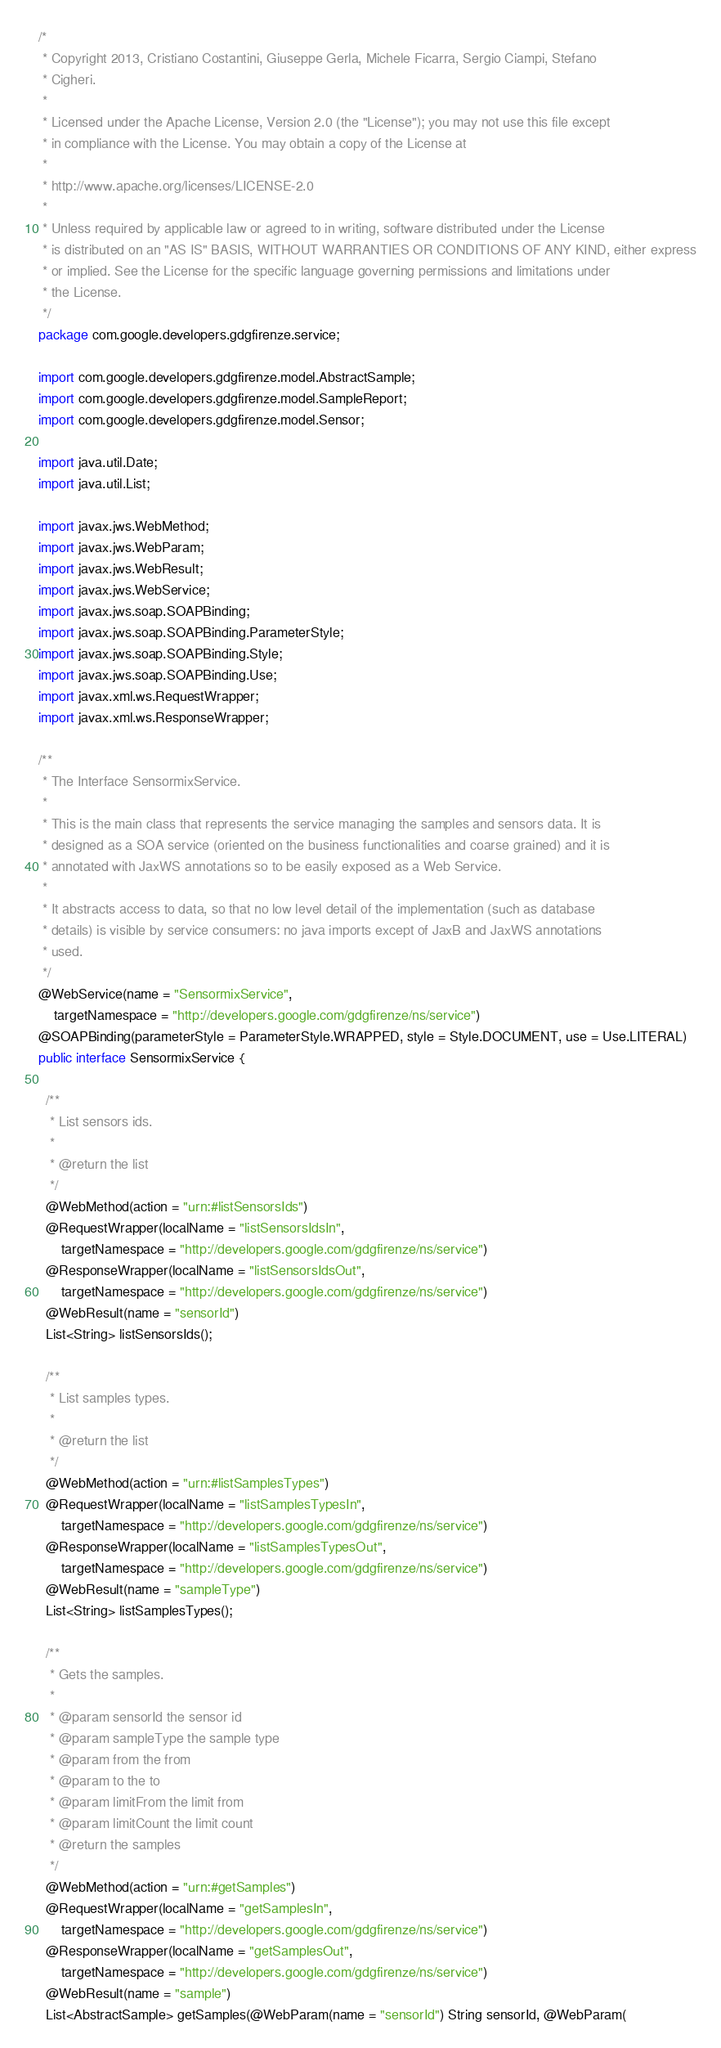<code> <loc_0><loc_0><loc_500><loc_500><_Java_>/*
 * Copyright 2013, Cristiano Costantini, Giuseppe Gerla, Michele Ficarra, Sergio Ciampi, Stefano
 * Cigheri.
 * 
 * Licensed under the Apache License, Version 2.0 (the "License"); you may not use this file except
 * in compliance with the License. You may obtain a copy of the License at
 * 
 * http://www.apache.org/licenses/LICENSE-2.0
 * 
 * Unless required by applicable law or agreed to in writing, software distributed under the License
 * is distributed on an "AS IS" BASIS, WITHOUT WARRANTIES OR CONDITIONS OF ANY KIND, either express
 * or implied. See the License for the specific language governing permissions and limitations under
 * the License.
 */
package com.google.developers.gdgfirenze.service;

import com.google.developers.gdgfirenze.model.AbstractSample;
import com.google.developers.gdgfirenze.model.SampleReport;
import com.google.developers.gdgfirenze.model.Sensor;

import java.util.Date;
import java.util.List;

import javax.jws.WebMethod;
import javax.jws.WebParam;
import javax.jws.WebResult;
import javax.jws.WebService;
import javax.jws.soap.SOAPBinding;
import javax.jws.soap.SOAPBinding.ParameterStyle;
import javax.jws.soap.SOAPBinding.Style;
import javax.jws.soap.SOAPBinding.Use;
import javax.xml.ws.RequestWrapper;
import javax.xml.ws.ResponseWrapper;

/**
 * The Interface SensormixService.
 * 
 * This is the main class that represents the service managing the samples and sensors data. It is
 * designed as a SOA service (oriented on the business functionalities and coarse grained) and it is
 * annotated with JaxWS annotations so to be easily exposed as a Web Service.
 * 
 * It abstracts access to data, so that no low level detail of the implementation (such as database
 * details) is visible by service consumers: no java imports except of JaxB and JaxWS annotations
 * used.
 */
@WebService(name = "SensormixService",
    targetNamespace = "http://developers.google.com/gdgfirenze/ns/service")
@SOAPBinding(parameterStyle = ParameterStyle.WRAPPED, style = Style.DOCUMENT, use = Use.LITERAL)
public interface SensormixService {

  /**
   * List sensors ids.
   * 
   * @return the list
   */
  @WebMethod(action = "urn:#listSensorsIds")
  @RequestWrapper(localName = "listSensorsIdsIn",
      targetNamespace = "http://developers.google.com/gdgfirenze/ns/service")
  @ResponseWrapper(localName = "listSensorsIdsOut",
      targetNamespace = "http://developers.google.com/gdgfirenze/ns/service")
  @WebResult(name = "sensorId")
  List<String> listSensorsIds();

  /**
   * List samples types.
   * 
   * @return the list
   */
  @WebMethod(action = "urn:#listSamplesTypes")
  @RequestWrapper(localName = "listSamplesTypesIn",
      targetNamespace = "http://developers.google.com/gdgfirenze/ns/service")
  @ResponseWrapper(localName = "listSamplesTypesOut",
      targetNamespace = "http://developers.google.com/gdgfirenze/ns/service")
  @WebResult(name = "sampleType")
  List<String> listSamplesTypes();

  /**
   * Gets the samples.
   * 
   * @param sensorId the sensor id
   * @param sampleType the sample type
   * @param from the from
   * @param to the to
   * @param limitFrom the limit from
   * @param limitCount the limit count
   * @return the samples
   */
  @WebMethod(action = "urn:#getSamples")
  @RequestWrapper(localName = "getSamplesIn",
      targetNamespace = "http://developers.google.com/gdgfirenze/ns/service")
  @ResponseWrapper(localName = "getSamplesOut",
      targetNamespace = "http://developers.google.com/gdgfirenze/ns/service")
  @WebResult(name = "sample")
  List<AbstractSample> getSamples(@WebParam(name = "sensorId") String sensorId, @WebParam(</code> 